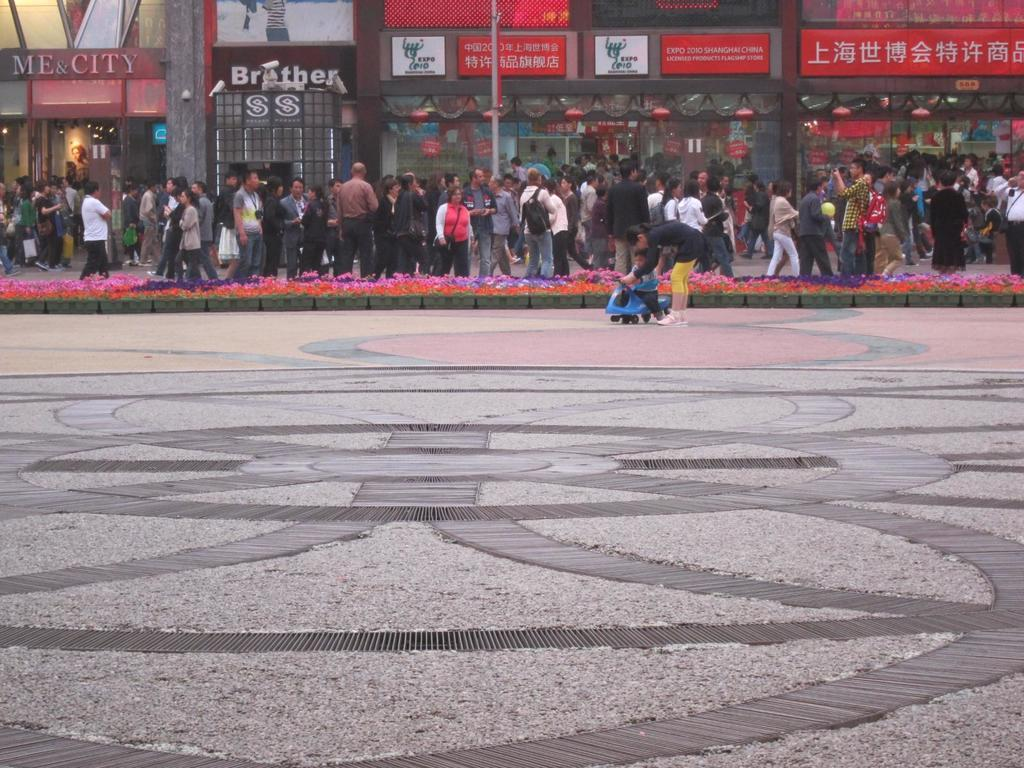What is the main subject of the image? The main subject of the image is a kid. What is the kid doing in the image? The kid is riding a toy vehicle. What can be seen in the middle of the image? There are people in the middle of the image. What type of structures are visible in the background of the image? There are boards and stores in the background of the image. How many women are present in the image? There is no information about women in the image; it only mentions a kid and people in the middle of the image. Can you see a yak in the image? There is no yak present in the image. 